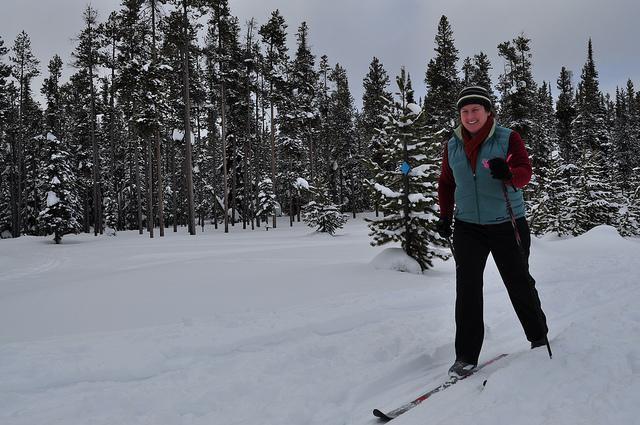How many people?
Give a very brief answer. 1. 